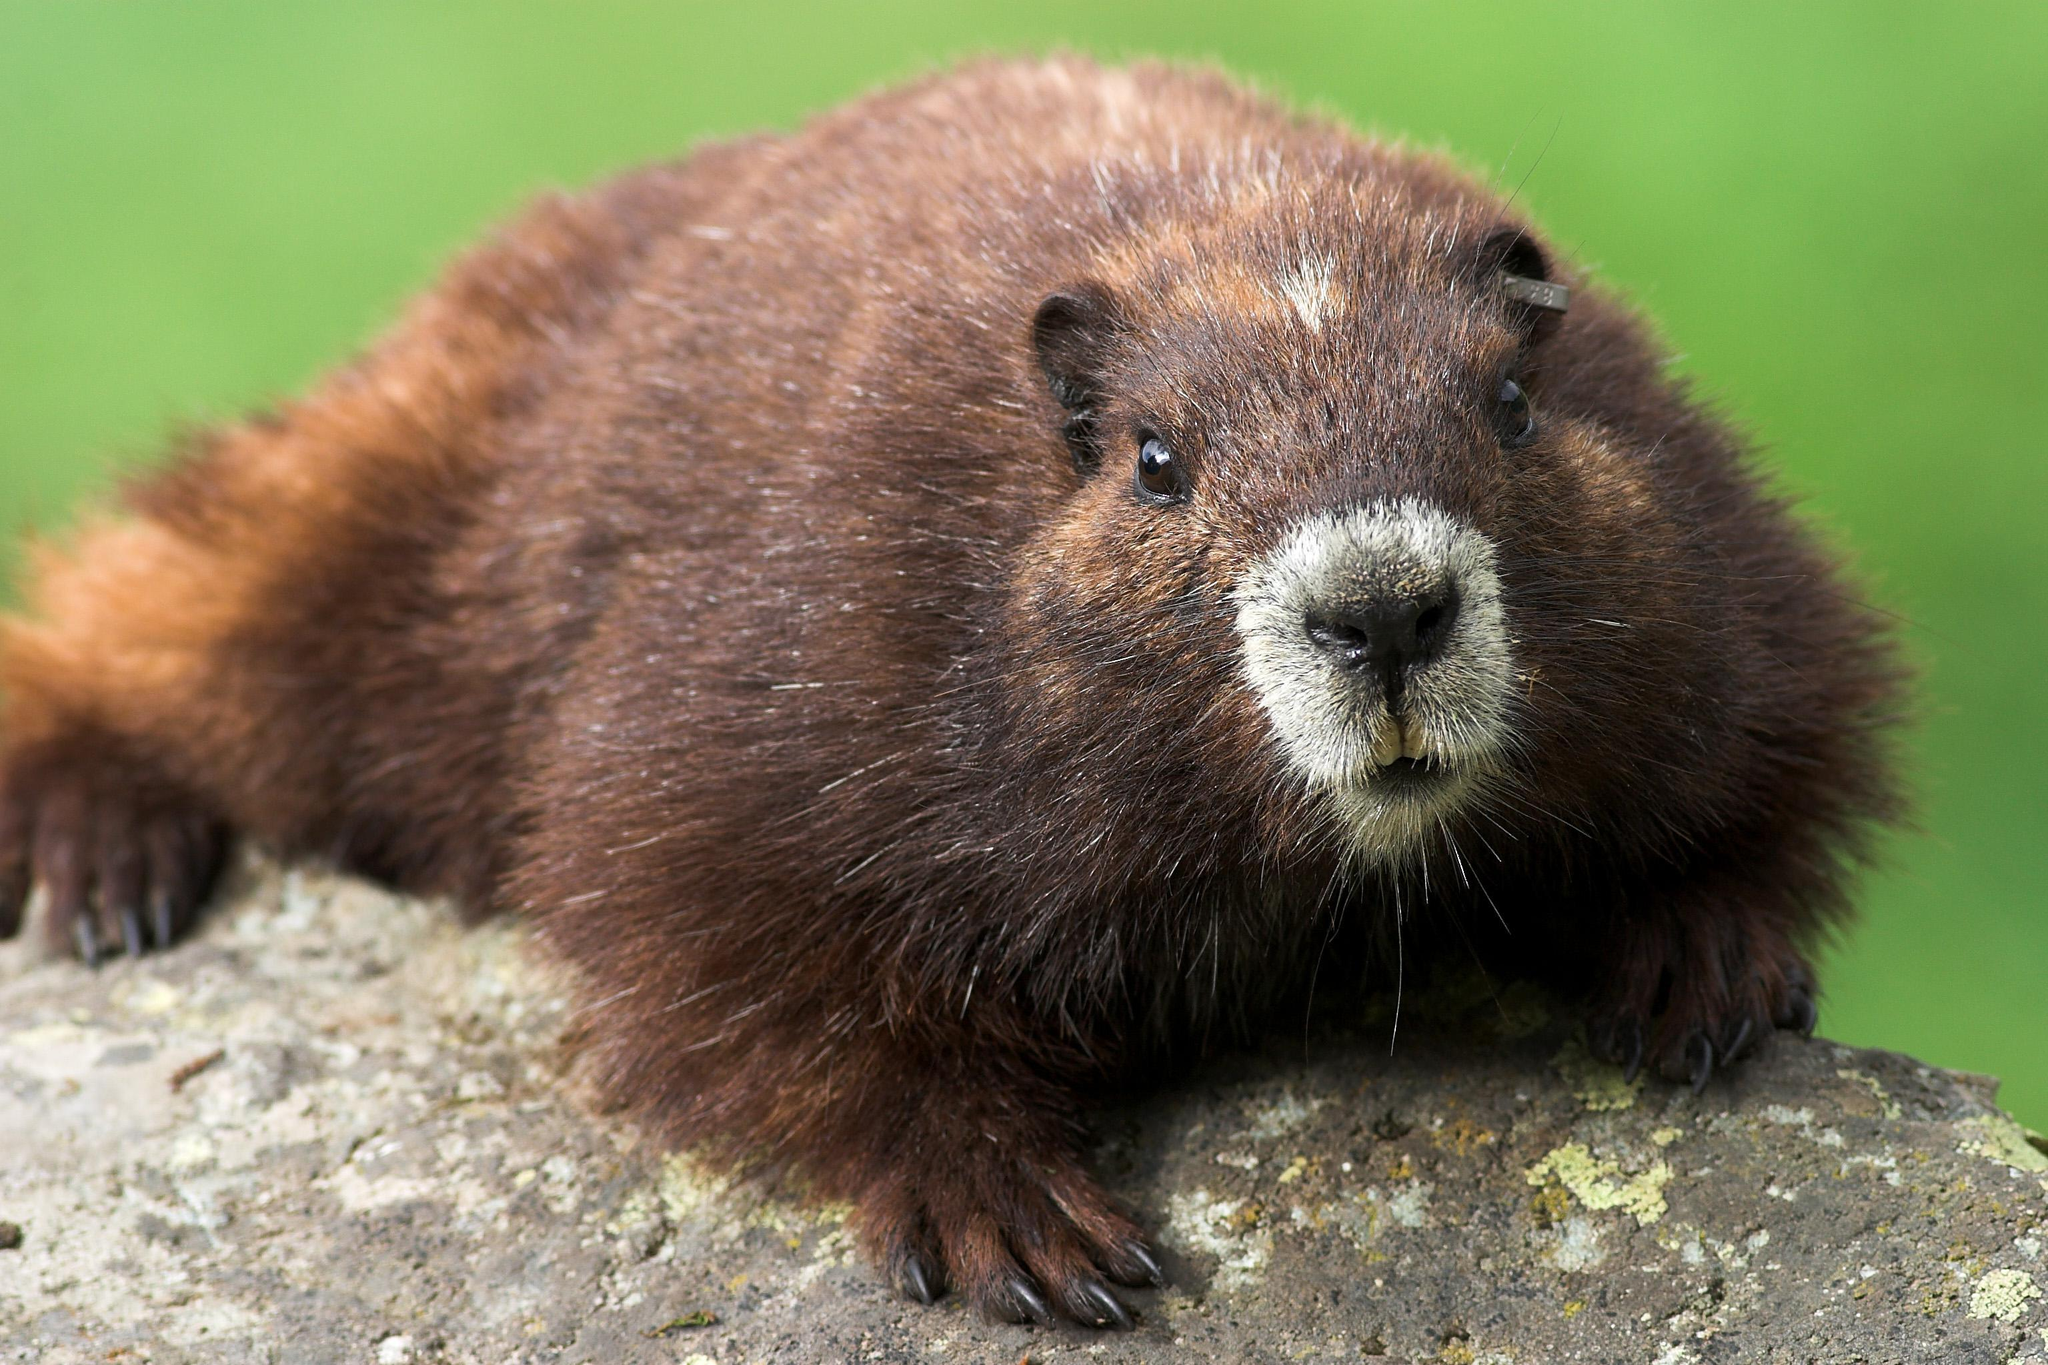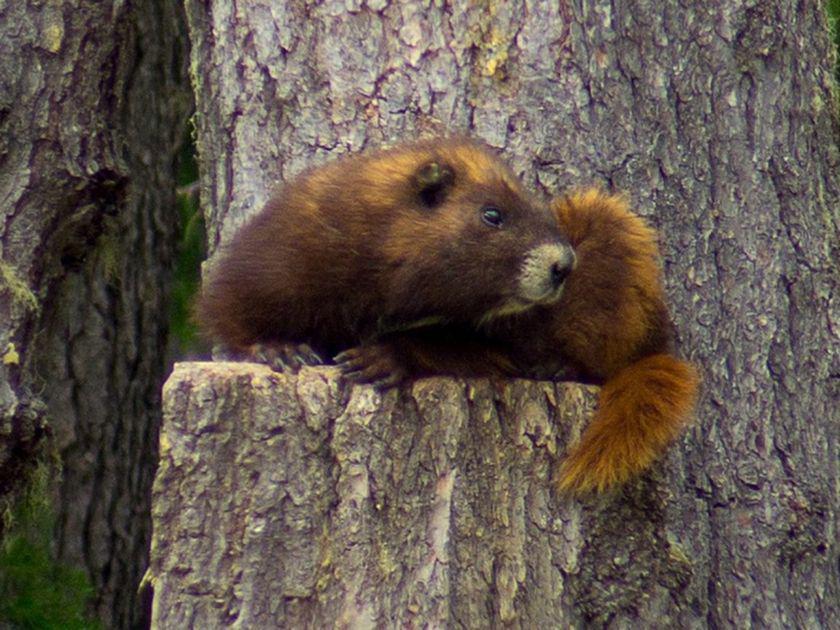The first image is the image on the left, the second image is the image on the right. Analyze the images presented: Is the assertion "The left and right image contains a total of three groundhogs." valid? Answer yes or no. No. The first image is the image on the left, the second image is the image on the right. Considering the images on both sides, is "One image contains twice as many marmots as the other image." valid? Answer yes or no. No. 